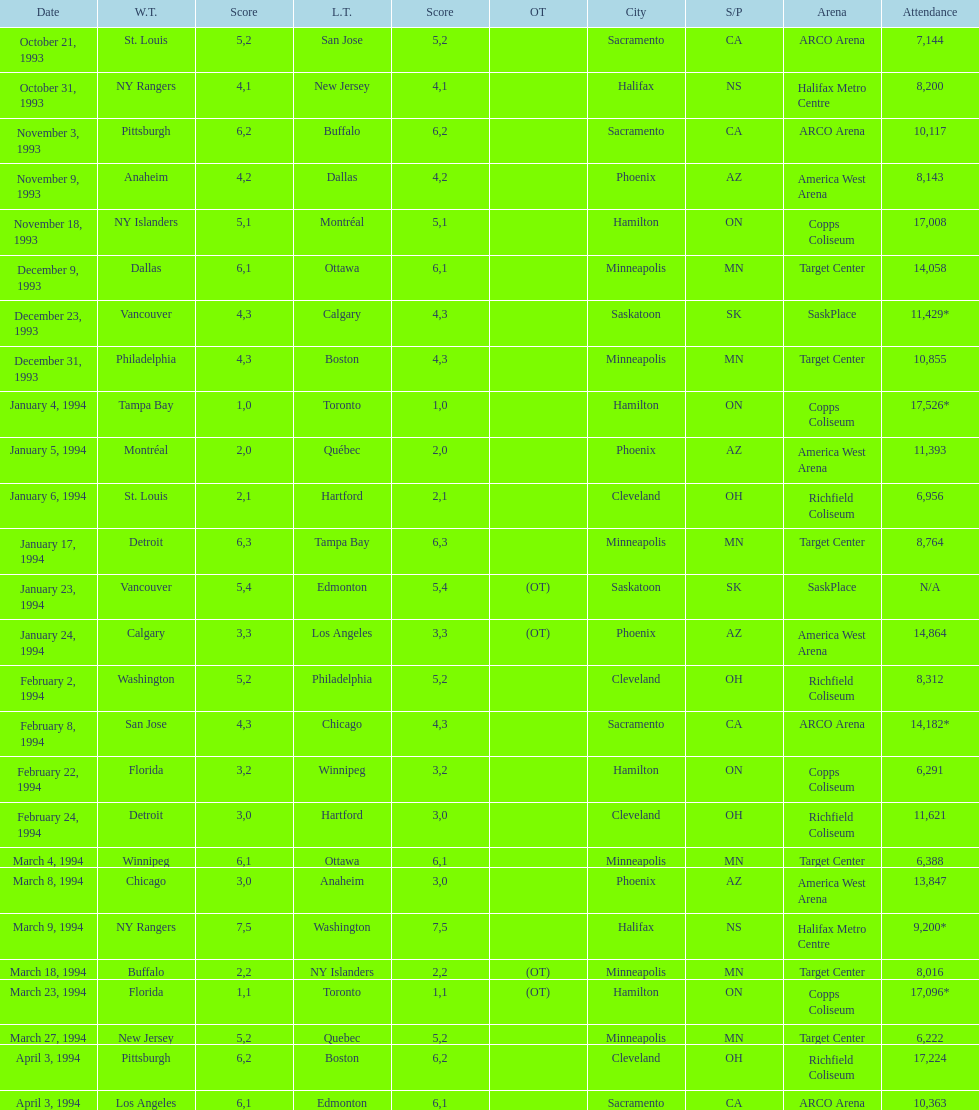Did dallas or ottawa win the december 9, 1993 game? Dallas. 